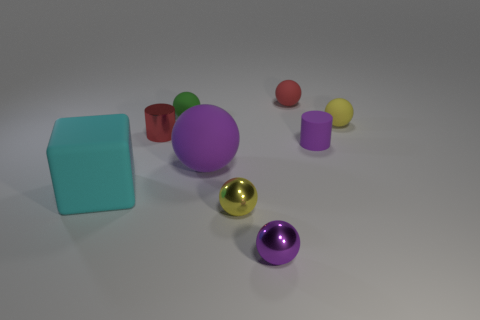How many objects are there in total, and can you categorize them by color? There are a total of eight objects. Categorizing by color, we have: two purple objects with different textures, a cyan cube, a golden sphere, a red sphere, a green sphere, a yellow sphere, and a pink sphere. 